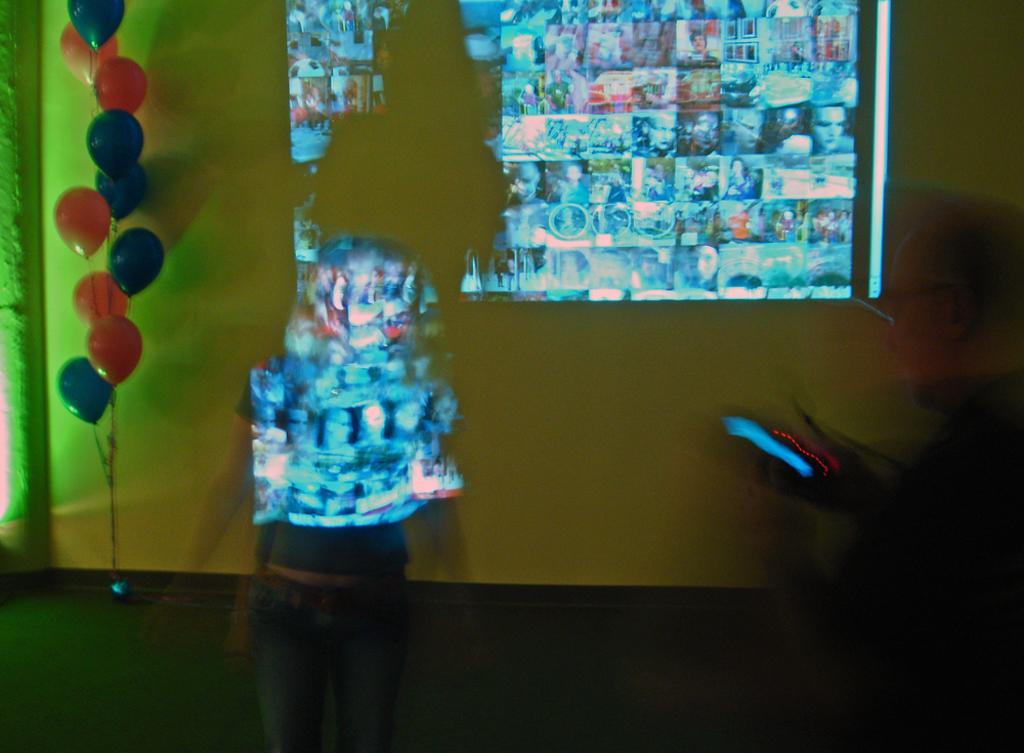How would you summarize this image in a sentence or two? In this image I see a woman over here and I see balloons over here which are of orange and blue in color and I see the floor. In the background I see the wall and I see a person over here who is blurred and I see few pictures displayed on the wall. 